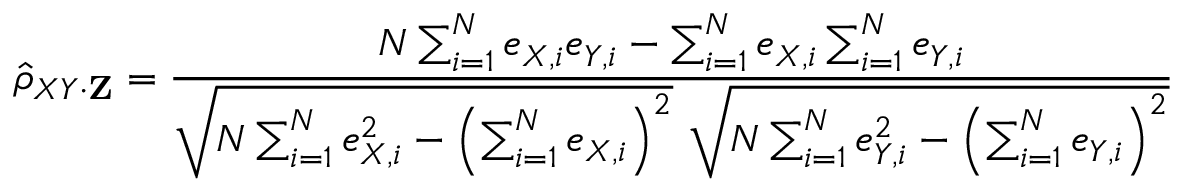Convert formula to latex. <formula><loc_0><loc_0><loc_500><loc_500>{ \hat { \rho } } _ { X Y \cdot Z } = { \frac { N \sum _ { i = 1 } ^ { N } e _ { X , i } e _ { Y , i } - \sum _ { i = 1 } ^ { N } e _ { X , i } \sum _ { i = 1 } ^ { N } e _ { Y , i } } { { \sqrt { N \sum _ { i = 1 } ^ { N } e _ { X , i } ^ { 2 } - \left ( \sum _ { i = 1 } ^ { N } e _ { X , i } \right ) ^ { 2 } } } { \sqrt { N \sum _ { i = 1 } ^ { N } e _ { Y , i } ^ { 2 } - \left ( \sum _ { i = 1 } ^ { N } e _ { Y , i } \right ) ^ { 2 } } } } }</formula> 